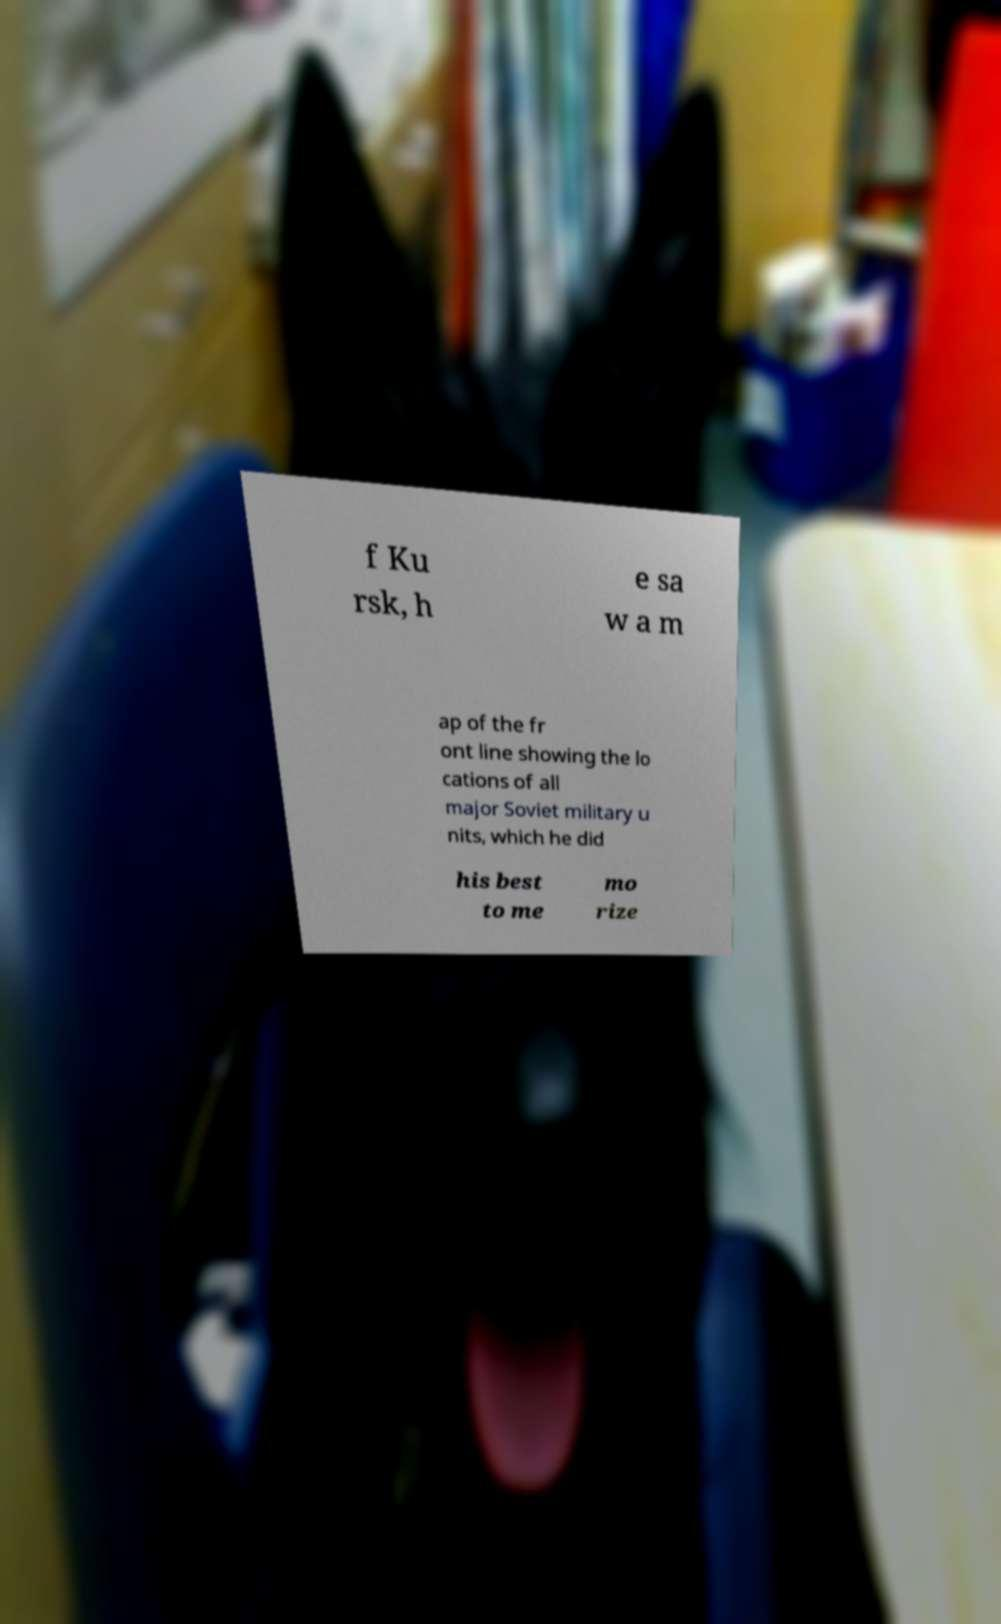Please read and relay the text visible in this image. What does it say? f Ku rsk, h e sa w a m ap of the fr ont line showing the lo cations of all major Soviet military u nits, which he did his best to me mo rize 